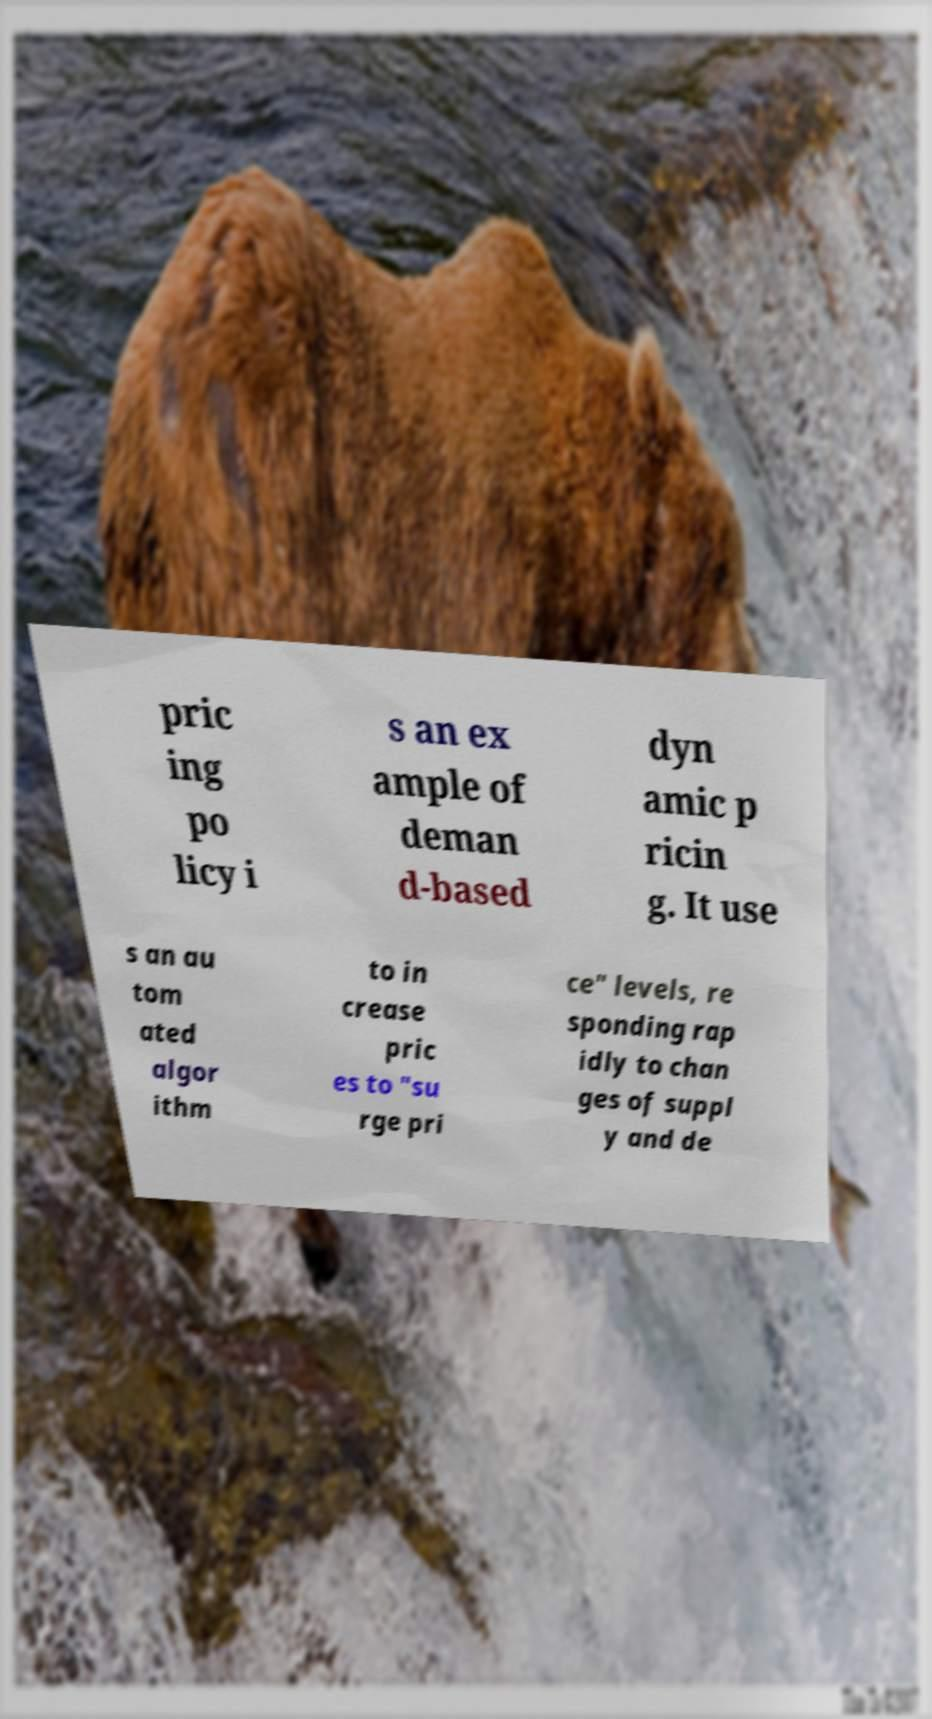Can you read and provide the text displayed in the image?This photo seems to have some interesting text. Can you extract and type it out for me? pric ing po licy i s an ex ample of deman d-based dyn amic p ricin g. It use s an au tom ated algor ithm to in crease pric es to "su rge pri ce" levels, re sponding rap idly to chan ges of suppl y and de 